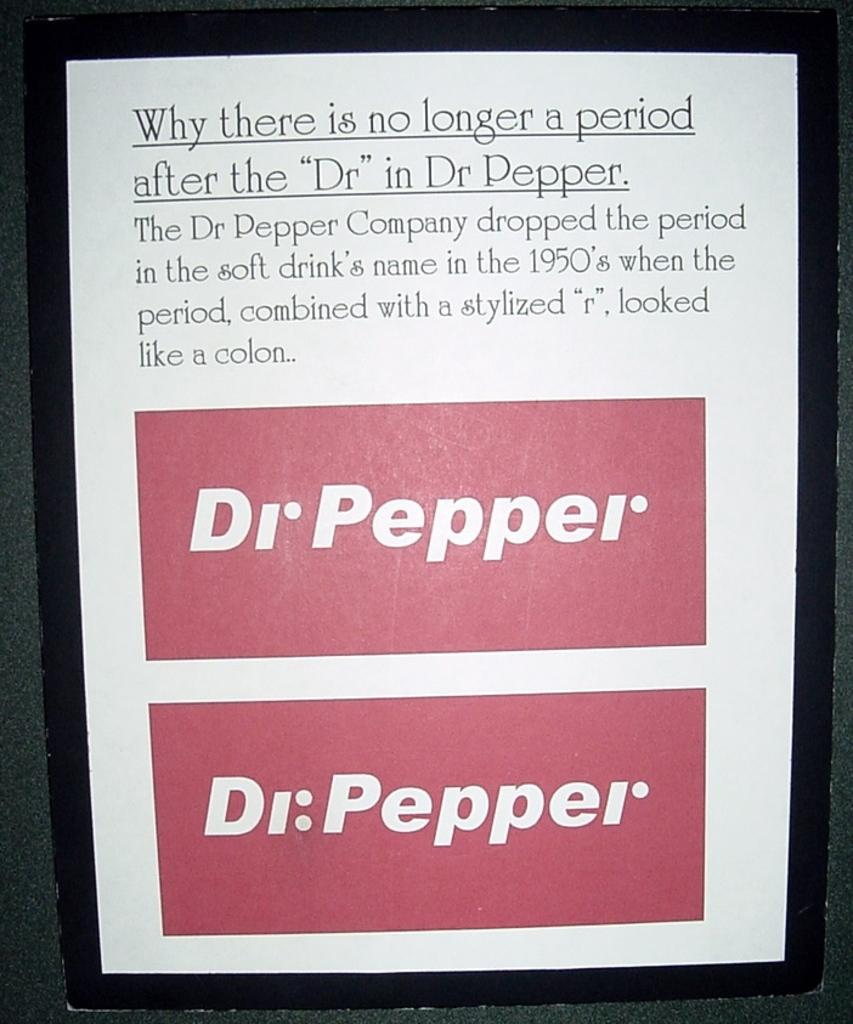Provide a one-sentence caption for the provided image. A poster explaining why there is not longer a period after the "Dr" in Dr Pepper. 